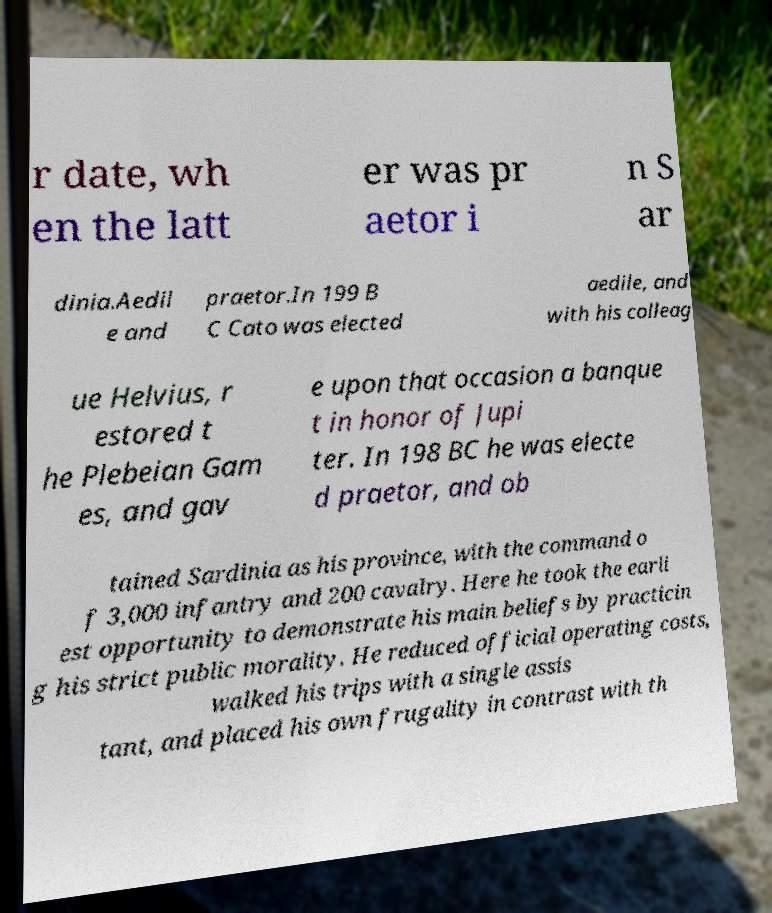Can you read and provide the text displayed in the image?This photo seems to have some interesting text. Can you extract and type it out for me? r date, wh en the latt er was pr aetor i n S ar dinia.Aedil e and praetor.In 199 B C Cato was elected aedile, and with his colleag ue Helvius, r estored t he Plebeian Gam es, and gav e upon that occasion a banque t in honor of Jupi ter. In 198 BC he was electe d praetor, and ob tained Sardinia as his province, with the command o f 3,000 infantry and 200 cavalry. Here he took the earli est opportunity to demonstrate his main beliefs by practicin g his strict public morality. He reduced official operating costs, walked his trips with a single assis tant, and placed his own frugality in contrast with th 